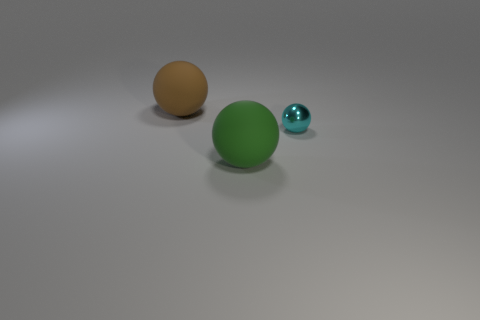Is there a large green thing of the same shape as the small object?
Your answer should be very brief. Yes. What number of things are brown objects or green rubber spheres right of the big brown ball?
Offer a terse response. 2. What color is the thing that is behind the tiny metal object?
Make the answer very short. Brown. Is the size of the rubber ball that is in front of the big brown matte sphere the same as the ball that is behind the small sphere?
Offer a terse response. Yes. Are there any purple metal things that have the same size as the green thing?
Provide a short and direct response. No. There is a object that is to the right of the green ball; how many large green matte spheres are in front of it?
Your response must be concise. 1. What is the material of the cyan object?
Your response must be concise. Metal. There is a metallic object; how many large brown objects are on the left side of it?
Make the answer very short. 1. Is the number of big gray rubber blocks greater than the number of small balls?
Your answer should be very brief. No. What size is the object that is right of the brown thing and left of the tiny sphere?
Provide a succinct answer. Large. 